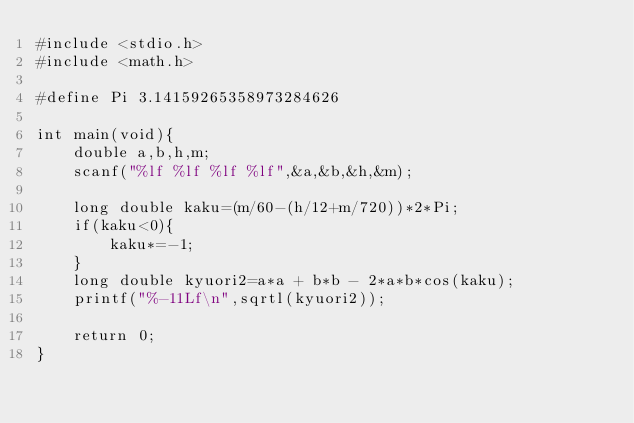<code> <loc_0><loc_0><loc_500><loc_500><_C_>#include <stdio.h>
#include <math.h>

#define Pi 3.14159265358973284626

int main(void){
    double a,b,h,m;
    scanf("%lf %lf %lf %lf",&a,&b,&h,&m);

    long double kaku=(m/60-(h/12+m/720))*2*Pi;
    if(kaku<0){
        kaku*=-1;
    }
    long double kyuori2=a*a + b*b - 2*a*b*cos(kaku);
    printf("%-11Lf\n",sqrtl(kyuori2));

    return 0;
}
</code> 